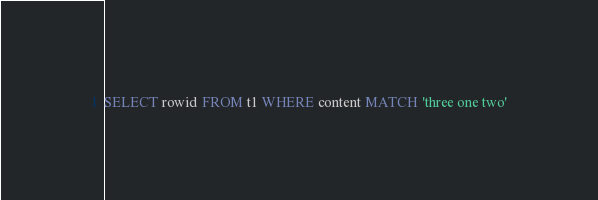Convert code to text. <code><loc_0><loc_0><loc_500><loc_500><_SQL_>SELECT rowid FROM t1 WHERE content MATCH 'three one two'</code> 